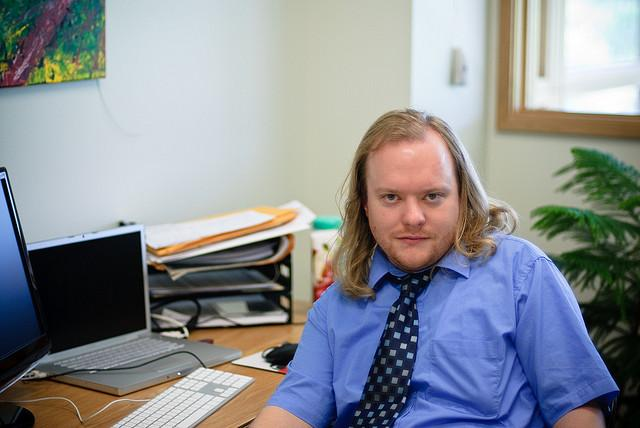What location does this man work in? office 